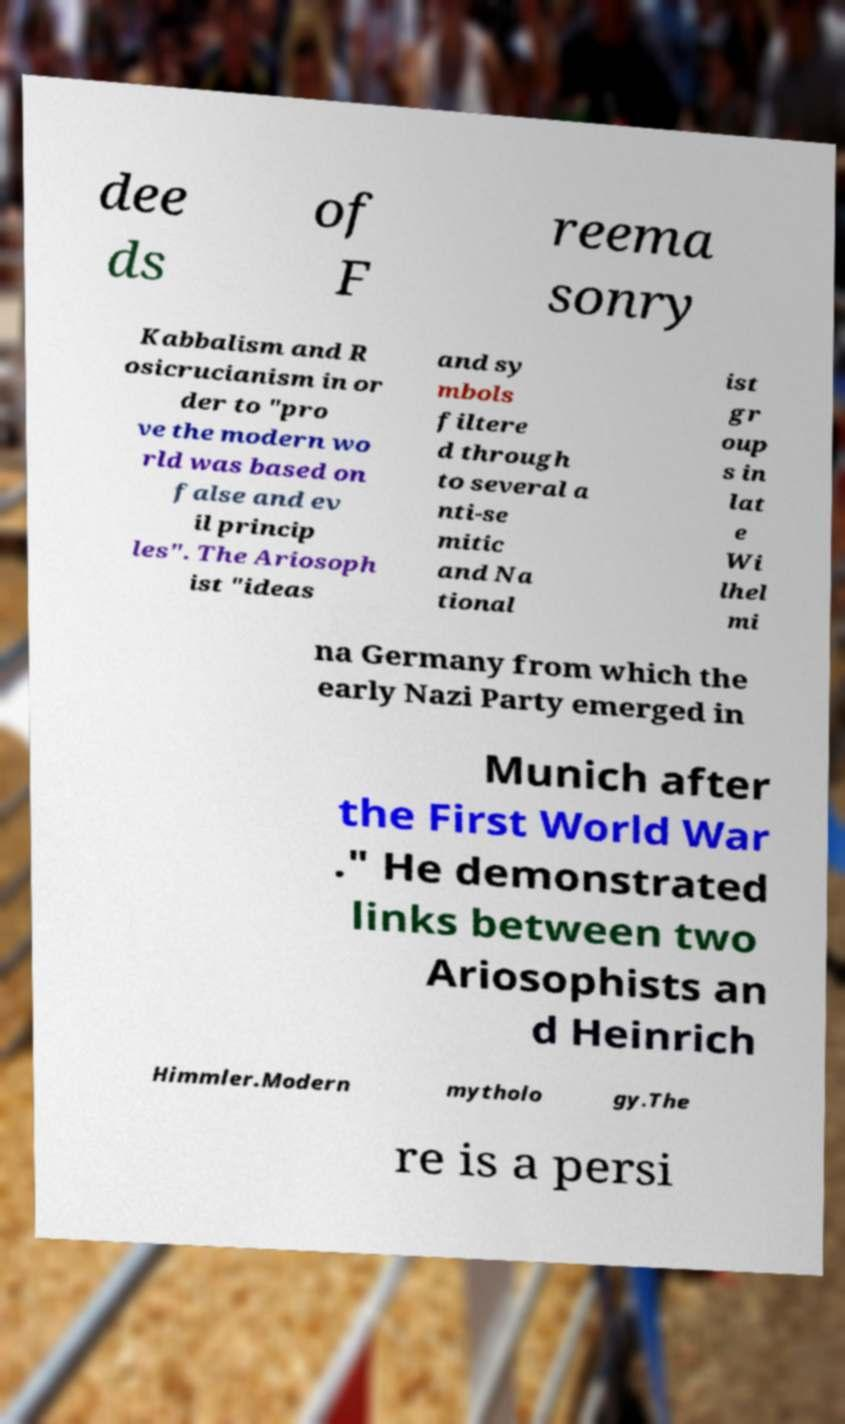Please identify and transcribe the text found in this image. dee ds of F reema sonry Kabbalism and R osicrucianism in or der to "pro ve the modern wo rld was based on false and ev il princip les". The Ariosoph ist "ideas and sy mbols filtere d through to several a nti-se mitic and Na tional ist gr oup s in lat e Wi lhel mi na Germany from which the early Nazi Party emerged in Munich after the First World War ." He demonstrated links between two Ariosophists an d Heinrich Himmler.Modern mytholo gy.The re is a persi 